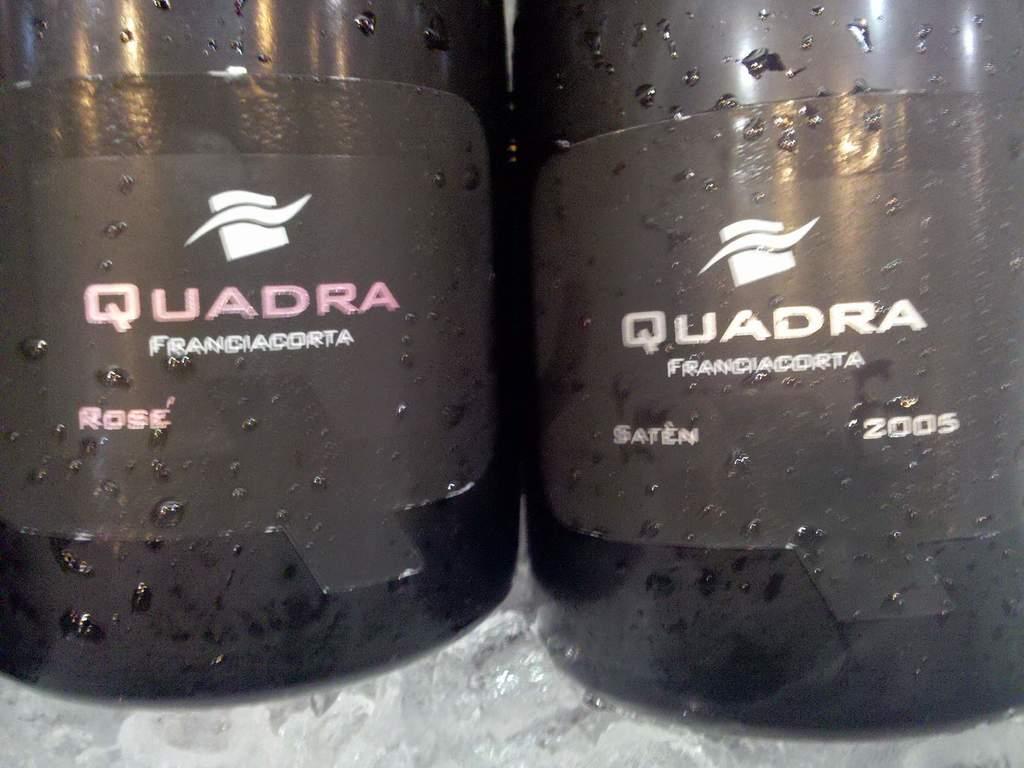What brand is this?
Provide a short and direct response. Quadra. 